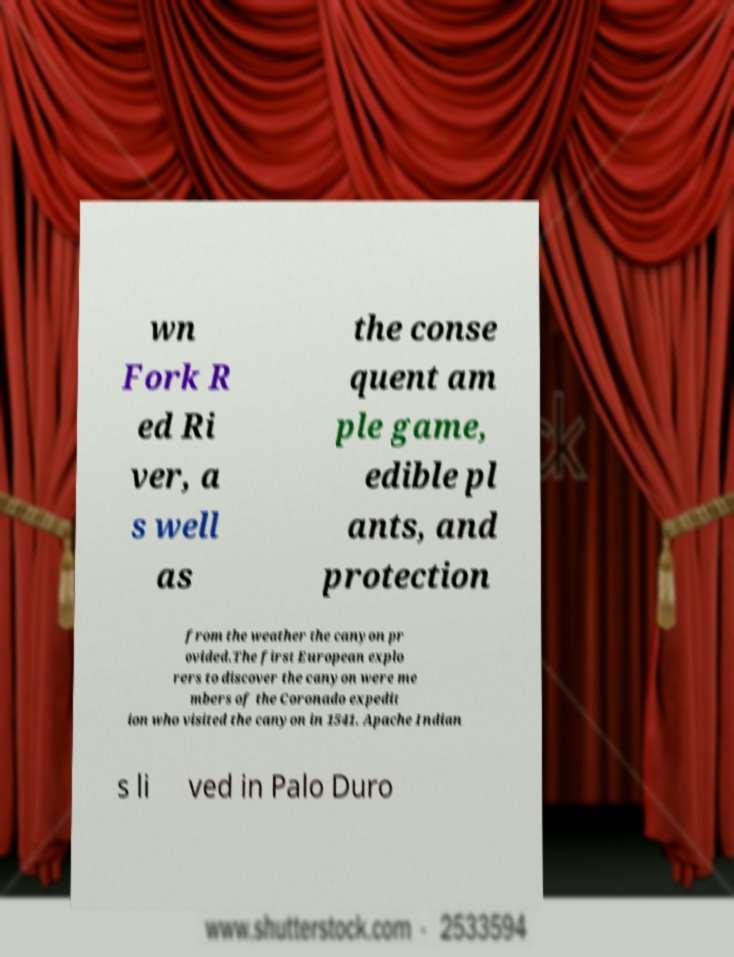Can you accurately transcribe the text from the provided image for me? wn Fork R ed Ri ver, a s well as the conse quent am ple game, edible pl ants, and protection from the weather the canyon pr ovided.The first European explo rers to discover the canyon were me mbers of the Coronado expedit ion who visited the canyon in 1541. Apache Indian s li ved in Palo Duro 